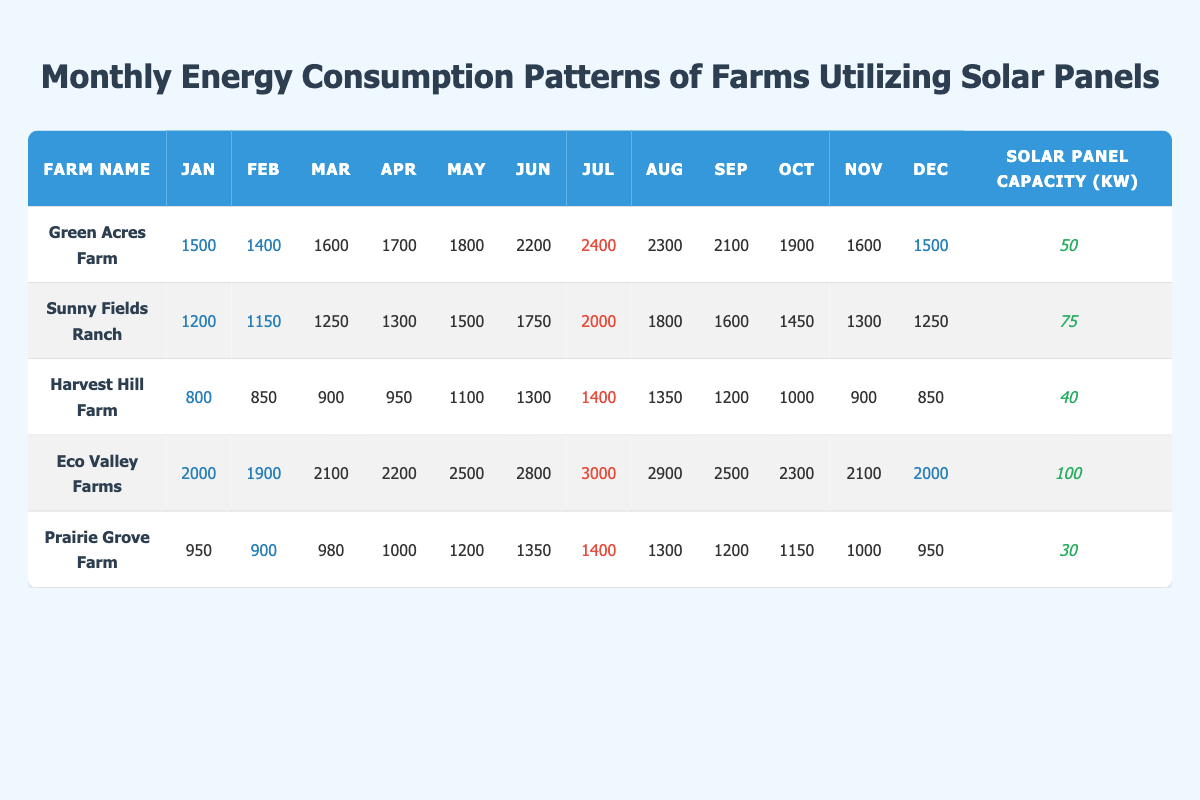What is the total monthly energy consumption of Eco Valley Farms in July? In the table, I found the energy consumption for Eco Valley Farms in July is listed as 3000 kWh. Since the question only asks for the value in July, I can provide that directly.
Answer: 3000 kWh Which farm has the highest monthly energy consumption in June? Looking through the June values in the table, Eco Valley Farms has the highest consumption at 2800 kWh, compared to the other farms listed.
Answer: Eco Valley Farms What is the average monthly energy consumption across all months for Green Acres Farm? First, I need to sum the monthly energy consumption values for Green Acres Farm: 1500 + 1400 + 1600 + 1700 + 1800 + 2200 + 2400 + 2300 + 2100 + 1900 + 1600 + 1500 = 20200 kWh. There are 12 months, so I divide the total by 12: 20200 / 12 = 1683.33 kWh.
Answer: 1683.33 kWh Does Sunny Fields Ranch consume more energy in the summer (June, July, August) than in the winter (December, January, February)? I will calculate the total energy consumption for the summer months: 1750 (June) + 2000 (July) + 1800 (August) = 5550 kWh. For winter: 1250 (December) + 1200 (January) + 1150 (February) = 3600 kWh. Since 5550 kWh is greater than 3600 kWh, Sunny Fields Ranch consumes more in the summer than in the winter.
Answer: Yes What is the difference in monthly energy consumption between Eco Valley Farms in July and Harvest Hill Farm in the same month? For Eco Valley Farms, the July consumption is 3000 kWh, while for Harvest Hill Farm, it is 1400 kWh. The difference is calculated as 3000 - 1400 = 1600 kWh.
Answer: 1600 kWh 